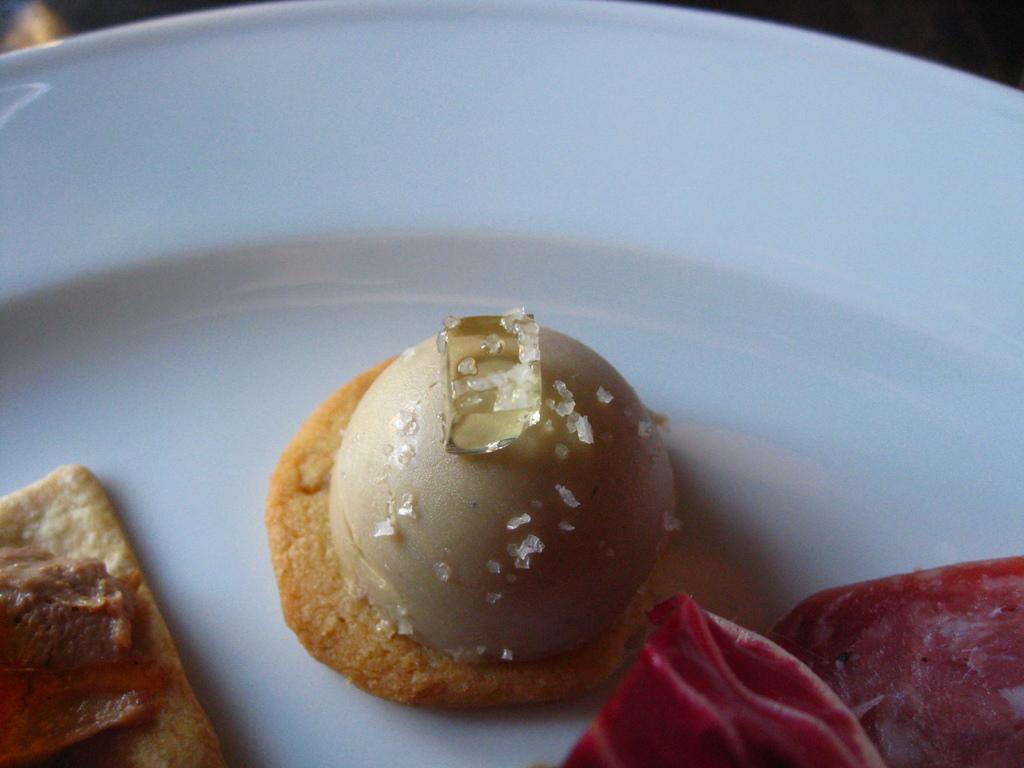Describe this image in one or two sentences. In this image, we can see a table, on that table, we can see some food item. In the background, we can see black color. 